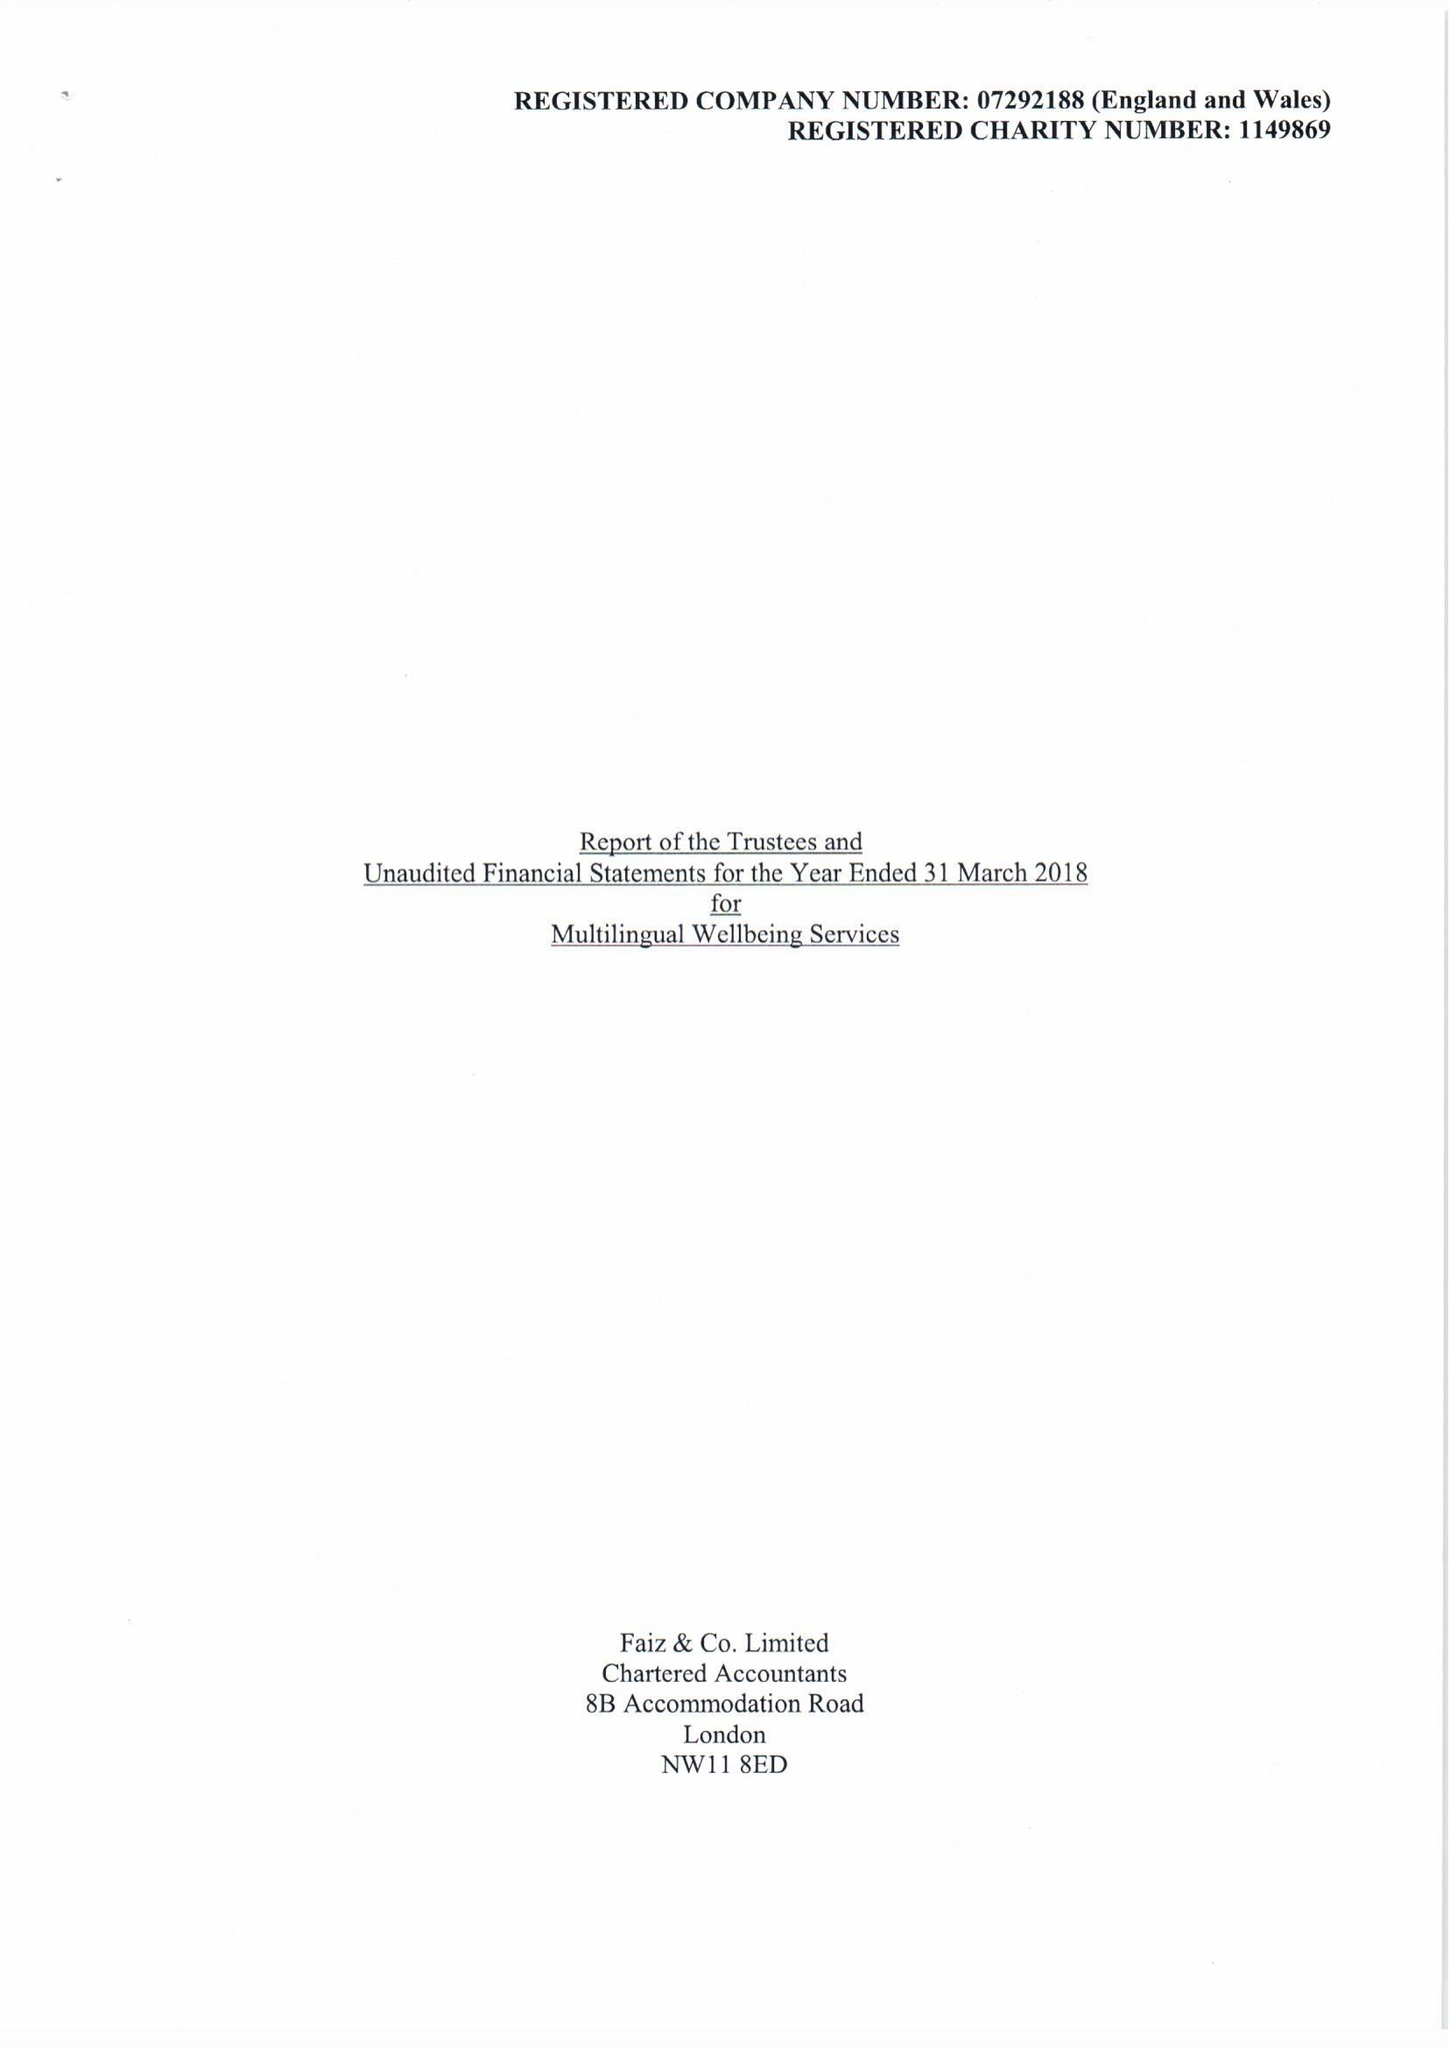What is the value for the address__postcode?
Answer the question using a single word or phrase. HA8 0AD 